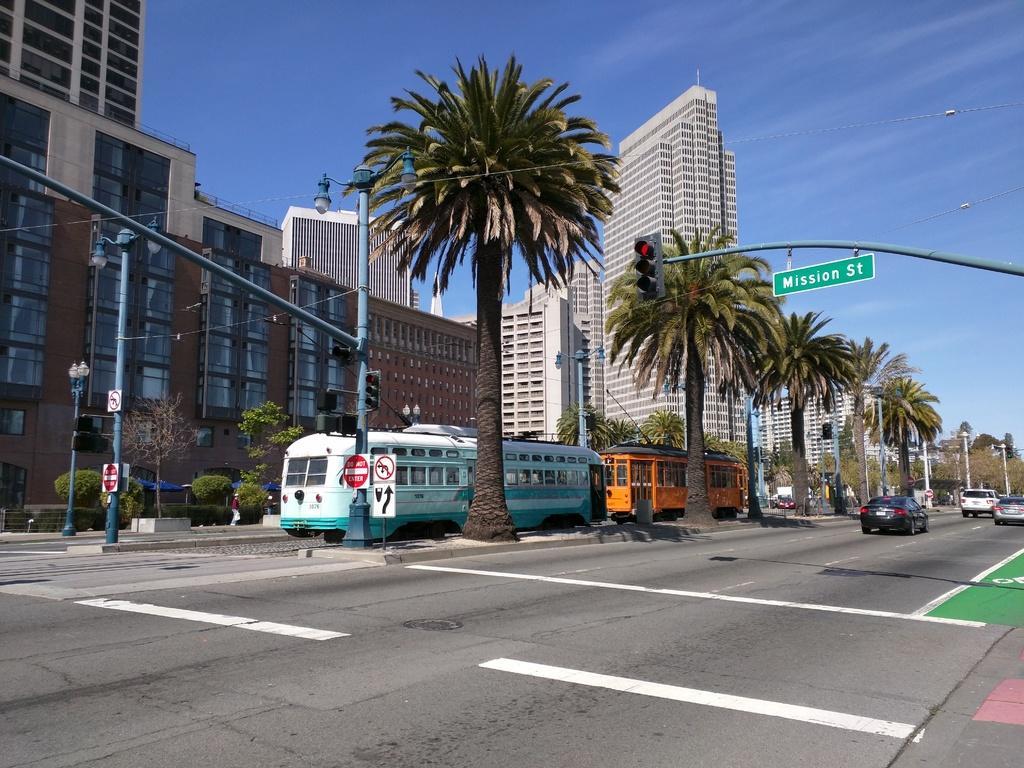Can you describe this image briefly? This picture is clicked outside the city. Here, we see cars moving on the road. Beside that, there are trees. Beside trees, we see buses are moving on the road. Beside them, we see street lights and a light pole. At the bottom of the picture, we see the road. In the background, there are buildings and trees. At the top of the picture, we see the sky. On the right side, we see a traffic signal and a board in green color with some text written on it. 